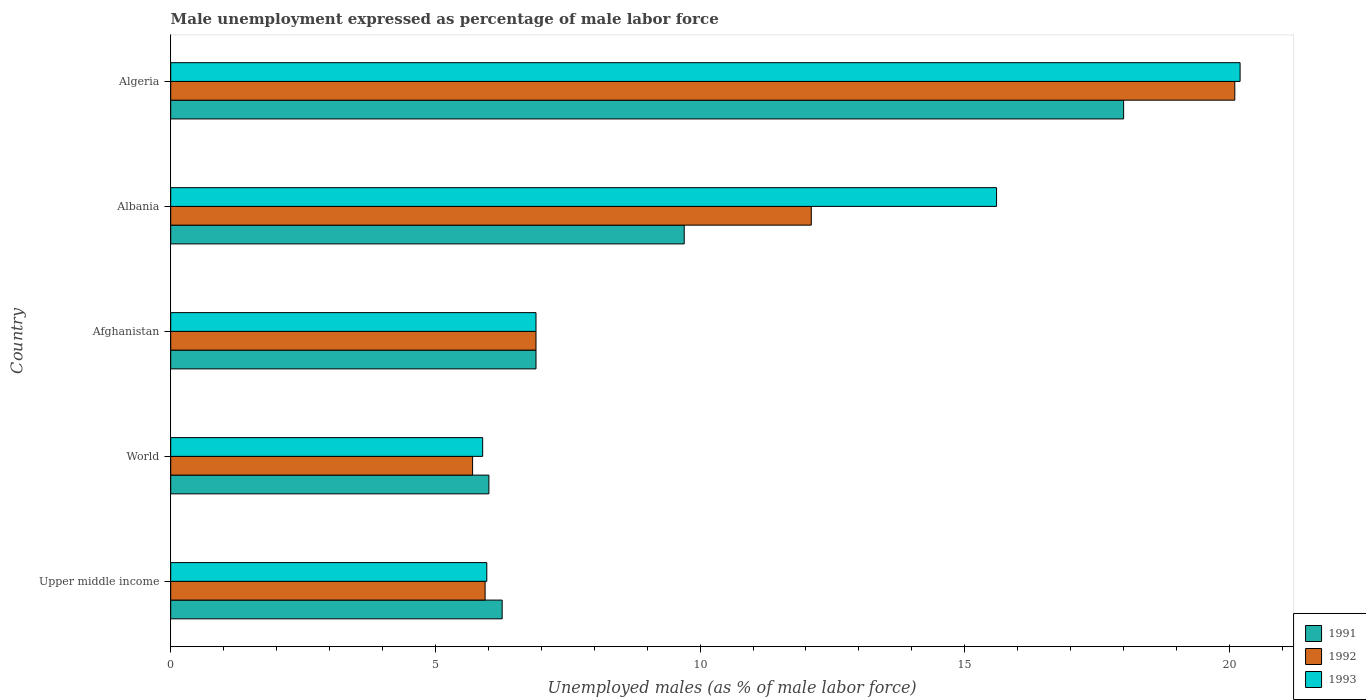How many groups of bars are there?
Your response must be concise. 5. Are the number of bars per tick equal to the number of legend labels?
Offer a terse response. Yes. Are the number of bars on each tick of the Y-axis equal?
Offer a terse response. Yes. How many bars are there on the 2nd tick from the top?
Offer a very short reply. 3. How many bars are there on the 5th tick from the bottom?
Your answer should be very brief. 3. What is the label of the 5th group of bars from the top?
Ensure brevity in your answer.  Upper middle income. In how many cases, is the number of bars for a given country not equal to the number of legend labels?
Offer a very short reply. 0. What is the unemployment in males in in 1992 in Afghanistan?
Offer a terse response. 6.9. Across all countries, what is the maximum unemployment in males in in 1993?
Provide a short and direct response. 20.2. Across all countries, what is the minimum unemployment in males in in 1993?
Provide a short and direct response. 5.89. In which country was the unemployment in males in in 1992 maximum?
Your answer should be compact. Algeria. What is the total unemployment in males in in 1991 in the graph?
Your response must be concise. 46.87. What is the difference between the unemployment in males in in 1993 in Afghanistan and that in Algeria?
Keep it short and to the point. -13.3. What is the difference between the unemployment in males in in 1992 in Albania and the unemployment in males in in 1993 in Upper middle income?
Keep it short and to the point. 6.13. What is the average unemployment in males in in 1991 per country?
Your answer should be very brief. 9.37. What is the difference between the unemployment in males in in 1991 and unemployment in males in in 1993 in Albania?
Your response must be concise. -5.9. What is the ratio of the unemployment in males in in 1992 in Afghanistan to that in Upper middle income?
Your answer should be very brief. 1.16. What is the difference between the highest and the second highest unemployment in males in in 1993?
Provide a succinct answer. 4.6. What is the difference between the highest and the lowest unemployment in males in in 1992?
Give a very brief answer. 14.4. In how many countries, is the unemployment in males in in 1993 greater than the average unemployment in males in in 1993 taken over all countries?
Your answer should be very brief. 2. What does the 2nd bar from the top in Afghanistan represents?
Ensure brevity in your answer.  1992. What does the 3rd bar from the bottom in Upper middle income represents?
Provide a succinct answer. 1993. How many bars are there?
Make the answer very short. 15. How many countries are there in the graph?
Offer a terse response. 5. Does the graph contain grids?
Offer a very short reply. No. Where does the legend appear in the graph?
Provide a succinct answer. Bottom right. How are the legend labels stacked?
Keep it short and to the point. Vertical. What is the title of the graph?
Ensure brevity in your answer.  Male unemployment expressed as percentage of male labor force. Does "1982" appear as one of the legend labels in the graph?
Make the answer very short. No. What is the label or title of the X-axis?
Your answer should be very brief. Unemployed males (as % of male labor force). What is the label or title of the Y-axis?
Ensure brevity in your answer.  Country. What is the Unemployed males (as % of male labor force) in 1991 in Upper middle income?
Your answer should be very brief. 6.26. What is the Unemployed males (as % of male labor force) of 1992 in Upper middle income?
Your response must be concise. 5.94. What is the Unemployed males (as % of male labor force) of 1993 in Upper middle income?
Provide a short and direct response. 5.97. What is the Unemployed males (as % of male labor force) in 1991 in World?
Your response must be concise. 6.01. What is the Unemployed males (as % of male labor force) of 1992 in World?
Keep it short and to the point. 5.7. What is the Unemployed males (as % of male labor force) of 1993 in World?
Your answer should be very brief. 5.89. What is the Unemployed males (as % of male labor force) of 1991 in Afghanistan?
Provide a short and direct response. 6.9. What is the Unemployed males (as % of male labor force) in 1992 in Afghanistan?
Offer a very short reply. 6.9. What is the Unemployed males (as % of male labor force) in 1993 in Afghanistan?
Your answer should be compact. 6.9. What is the Unemployed males (as % of male labor force) in 1991 in Albania?
Give a very brief answer. 9.7. What is the Unemployed males (as % of male labor force) in 1992 in Albania?
Your answer should be compact. 12.1. What is the Unemployed males (as % of male labor force) of 1993 in Albania?
Provide a succinct answer. 15.6. What is the Unemployed males (as % of male labor force) in 1991 in Algeria?
Make the answer very short. 18. What is the Unemployed males (as % of male labor force) of 1992 in Algeria?
Make the answer very short. 20.1. What is the Unemployed males (as % of male labor force) in 1993 in Algeria?
Your response must be concise. 20.2. Across all countries, what is the maximum Unemployed males (as % of male labor force) in 1992?
Provide a short and direct response. 20.1. Across all countries, what is the maximum Unemployed males (as % of male labor force) in 1993?
Your answer should be compact. 20.2. Across all countries, what is the minimum Unemployed males (as % of male labor force) in 1991?
Give a very brief answer. 6.01. Across all countries, what is the minimum Unemployed males (as % of male labor force) in 1992?
Provide a short and direct response. 5.7. Across all countries, what is the minimum Unemployed males (as % of male labor force) in 1993?
Make the answer very short. 5.89. What is the total Unemployed males (as % of male labor force) in 1991 in the graph?
Provide a succinct answer. 46.87. What is the total Unemployed males (as % of male labor force) in 1992 in the graph?
Your answer should be very brief. 50.74. What is the total Unemployed males (as % of male labor force) in 1993 in the graph?
Make the answer very short. 54.56. What is the difference between the Unemployed males (as % of male labor force) of 1991 in Upper middle income and that in World?
Make the answer very short. 0.25. What is the difference between the Unemployed males (as % of male labor force) of 1992 in Upper middle income and that in World?
Offer a terse response. 0.24. What is the difference between the Unemployed males (as % of male labor force) in 1993 in Upper middle income and that in World?
Give a very brief answer. 0.08. What is the difference between the Unemployed males (as % of male labor force) of 1991 in Upper middle income and that in Afghanistan?
Ensure brevity in your answer.  -0.64. What is the difference between the Unemployed males (as % of male labor force) in 1992 in Upper middle income and that in Afghanistan?
Provide a short and direct response. -0.96. What is the difference between the Unemployed males (as % of male labor force) in 1993 in Upper middle income and that in Afghanistan?
Give a very brief answer. -0.93. What is the difference between the Unemployed males (as % of male labor force) in 1991 in Upper middle income and that in Albania?
Offer a very short reply. -3.44. What is the difference between the Unemployed males (as % of male labor force) in 1992 in Upper middle income and that in Albania?
Offer a terse response. -6.16. What is the difference between the Unemployed males (as % of male labor force) in 1993 in Upper middle income and that in Albania?
Provide a succinct answer. -9.63. What is the difference between the Unemployed males (as % of male labor force) of 1991 in Upper middle income and that in Algeria?
Keep it short and to the point. -11.74. What is the difference between the Unemployed males (as % of male labor force) of 1992 in Upper middle income and that in Algeria?
Provide a short and direct response. -14.16. What is the difference between the Unemployed males (as % of male labor force) of 1993 in Upper middle income and that in Algeria?
Keep it short and to the point. -14.23. What is the difference between the Unemployed males (as % of male labor force) of 1991 in World and that in Afghanistan?
Offer a very short reply. -0.89. What is the difference between the Unemployed males (as % of male labor force) in 1992 in World and that in Afghanistan?
Your answer should be very brief. -1.2. What is the difference between the Unemployed males (as % of male labor force) in 1993 in World and that in Afghanistan?
Your answer should be compact. -1.01. What is the difference between the Unemployed males (as % of male labor force) in 1991 in World and that in Albania?
Your answer should be compact. -3.69. What is the difference between the Unemployed males (as % of male labor force) of 1992 in World and that in Albania?
Make the answer very short. -6.4. What is the difference between the Unemployed males (as % of male labor force) of 1993 in World and that in Albania?
Make the answer very short. -9.71. What is the difference between the Unemployed males (as % of male labor force) in 1991 in World and that in Algeria?
Your response must be concise. -11.99. What is the difference between the Unemployed males (as % of male labor force) in 1992 in World and that in Algeria?
Make the answer very short. -14.4. What is the difference between the Unemployed males (as % of male labor force) in 1993 in World and that in Algeria?
Ensure brevity in your answer.  -14.31. What is the difference between the Unemployed males (as % of male labor force) of 1991 in Afghanistan and that in Albania?
Your response must be concise. -2.8. What is the difference between the Unemployed males (as % of male labor force) of 1992 in Afghanistan and that in Albania?
Offer a terse response. -5.2. What is the difference between the Unemployed males (as % of male labor force) in 1993 in Afghanistan and that in Albania?
Offer a terse response. -8.7. What is the difference between the Unemployed males (as % of male labor force) in 1991 in Afghanistan and that in Algeria?
Keep it short and to the point. -11.1. What is the difference between the Unemployed males (as % of male labor force) in 1992 in Afghanistan and that in Algeria?
Make the answer very short. -13.2. What is the difference between the Unemployed males (as % of male labor force) in 1993 in Afghanistan and that in Algeria?
Offer a very short reply. -13.3. What is the difference between the Unemployed males (as % of male labor force) in 1991 in Upper middle income and the Unemployed males (as % of male labor force) in 1992 in World?
Provide a succinct answer. 0.56. What is the difference between the Unemployed males (as % of male labor force) in 1991 in Upper middle income and the Unemployed males (as % of male labor force) in 1993 in World?
Keep it short and to the point. 0.37. What is the difference between the Unemployed males (as % of male labor force) of 1992 in Upper middle income and the Unemployed males (as % of male labor force) of 1993 in World?
Provide a short and direct response. 0.05. What is the difference between the Unemployed males (as % of male labor force) in 1991 in Upper middle income and the Unemployed males (as % of male labor force) in 1992 in Afghanistan?
Offer a very short reply. -0.64. What is the difference between the Unemployed males (as % of male labor force) in 1991 in Upper middle income and the Unemployed males (as % of male labor force) in 1993 in Afghanistan?
Your response must be concise. -0.64. What is the difference between the Unemployed males (as % of male labor force) in 1992 in Upper middle income and the Unemployed males (as % of male labor force) in 1993 in Afghanistan?
Keep it short and to the point. -0.96. What is the difference between the Unemployed males (as % of male labor force) in 1991 in Upper middle income and the Unemployed males (as % of male labor force) in 1992 in Albania?
Your answer should be very brief. -5.84. What is the difference between the Unemployed males (as % of male labor force) of 1991 in Upper middle income and the Unemployed males (as % of male labor force) of 1993 in Albania?
Ensure brevity in your answer.  -9.34. What is the difference between the Unemployed males (as % of male labor force) of 1992 in Upper middle income and the Unemployed males (as % of male labor force) of 1993 in Albania?
Ensure brevity in your answer.  -9.66. What is the difference between the Unemployed males (as % of male labor force) of 1991 in Upper middle income and the Unemployed males (as % of male labor force) of 1992 in Algeria?
Provide a succinct answer. -13.84. What is the difference between the Unemployed males (as % of male labor force) of 1991 in Upper middle income and the Unemployed males (as % of male labor force) of 1993 in Algeria?
Your response must be concise. -13.94. What is the difference between the Unemployed males (as % of male labor force) in 1992 in Upper middle income and the Unemployed males (as % of male labor force) in 1993 in Algeria?
Give a very brief answer. -14.26. What is the difference between the Unemployed males (as % of male labor force) in 1991 in World and the Unemployed males (as % of male labor force) in 1992 in Afghanistan?
Ensure brevity in your answer.  -0.89. What is the difference between the Unemployed males (as % of male labor force) of 1991 in World and the Unemployed males (as % of male labor force) of 1993 in Afghanistan?
Ensure brevity in your answer.  -0.89. What is the difference between the Unemployed males (as % of male labor force) in 1992 in World and the Unemployed males (as % of male labor force) in 1993 in Afghanistan?
Ensure brevity in your answer.  -1.2. What is the difference between the Unemployed males (as % of male labor force) in 1991 in World and the Unemployed males (as % of male labor force) in 1992 in Albania?
Provide a succinct answer. -6.09. What is the difference between the Unemployed males (as % of male labor force) in 1991 in World and the Unemployed males (as % of male labor force) in 1993 in Albania?
Give a very brief answer. -9.59. What is the difference between the Unemployed males (as % of male labor force) in 1992 in World and the Unemployed males (as % of male labor force) in 1993 in Albania?
Offer a very short reply. -9.9. What is the difference between the Unemployed males (as % of male labor force) in 1991 in World and the Unemployed males (as % of male labor force) in 1992 in Algeria?
Provide a succinct answer. -14.09. What is the difference between the Unemployed males (as % of male labor force) of 1991 in World and the Unemployed males (as % of male labor force) of 1993 in Algeria?
Your response must be concise. -14.19. What is the difference between the Unemployed males (as % of male labor force) in 1992 in World and the Unemployed males (as % of male labor force) in 1993 in Algeria?
Ensure brevity in your answer.  -14.5. What is the difference between the Unemployed males (as % of male labor force) in 1991 in Afghanistan and the Unemployed males (as % of male labor force) in 1992 in Albania?
Ensure brevity in your answer.  -5.2. What is the difference between the Unemployed males (as % of male labor force) in 1992 in Afghanistan and the Unemployed males (as % of male labor force) in 1993 in Albania?
Your answer should be very brief. -8.7. What is the difference between the Unemployed males (as % of male labor force) in 1991 in Afghanistan and the Unemployed males (as % of male labor force) in 1992 in Algeria?
Offer a terse response. -13.2. What is the difference between the Unemployed males (as % of male labor force) in 1992 in Afghanistan and the Unemployed males (as % of male labor force) in 1993 in Algeria?
Give a very brief answer. -13.3. What is the difference between the Unemployed males (as % of male labor force) in 1992 in Albania and the Unemployed males (as % of male labor force) in 1993 in Algeria?
Provide a short and direct response. -8.1. What is the average Unemployed males (as % of male labor force) of 1991 per country?
Your response must be concise. 9.37. What is the average Unemployed males (as % of male labor force) of 1992 per country?
Ensure brevity in your answer.  10.15. What is the average Unemployed males (as % of male labor force) in 1993 per country?
Ensure brevity in your answer.  10.91. What is the difference between the Unemployed males (as % of male labor force) of 1991 and Unemployed males (as % of male labor force) of 1992 in Upper middle income?
Ensure brevity in your answer.  0.32. What is the difference between the Unemployed males (as % of male labor force) in 1991 and Unemployed males (as % of male labor force) in 1993 in Upper middle income?
Give a very brief answer. 0.29. What is the difference between the Unemployed males (as % of male labor force) in 1992 and Unemployed males (as % of male labor force) in 1993 in Upper middle income?
Offer a very short reply. -0.03. What is the difference between the Unemployed males (as % of male labor force) in 1991 and Unemployed males (as % of male labor force) in 1992 in World?
Your response must be concise. 0.31. What is the difference between the Unemployed males (as % of male labor force) in 1991 and Unemployed males (as % of male labor force) in 1993 in World?
Keep it short and to the point. 0.12. What is the difference between the Unemployed males (as % of male labor force) in 1992 and Unemployed males (as % of male labor force) in 1993 in World?
Offer a terse response. -0.19. What is the difference between the Unemployed males (as % of male labor force) of 1991 and Unemployed males (as % of male labor force) of 1992 in Afghanistan?
Your answer should be compact. 0. What is the difference between the Unemployed males (as % of male labor force) of 1992 and Unemployed males (as % of male labor force) of 1993 in Afghanistan?
Offer a very short reply. 0. What is the difference between the Unemployed males (as % of male labor force) of 1992 and Unemployed males (as % of male labor force) of 1993 in Algeria?
Your answer should be very brief. -0.1. What is the ratio of the Unemployed males (as % of male labor force) of 1991 in Upper middle income to that in World?
Offer a very short reply. 1.04. What is the ratio of the Unemployed males (as % of male labor force) in 1992 in Upper middle income to that in World?
Provide a succinct answer. 1.04. What is the ratio of the Unemployed males (as % of male labor force) in 1993 in Upper middle income to that in World?
Your answer should be compact. 1.01. What is the ratio of the Unemployed males (as % of male labor force) in 1991 in Upper middle income to that in Afghanistan?
Offer a very short reply. 0.91. What is the ratio of the Unemployed males (as % of male labor force) of 1992 in Upper middle income to that in Afghanistan?
Provide a succinct answer. 0.86. What is the ratio of the Unemployed males (as % of male labor force) in 1993 in Upper middle income to that in Afghanistan?
Keep it short and to the point. 0.87. What is the ratio of the Unemployed males (as % of male labor force) in 1991 in Upper middle income to that in Albania?
Give a very brief answer. 0.65. What is the ratio of the Unemployed males (as % of male labor force) of 1992 in Upper middle income to that in Albania?
Provide a succinct answer. 0.49. What is the ratio of the Unemployed males (as % of male labor force) of 1993 in Upper middle income to that in Albania?
Offer a very short reply. 0.38. What is the ratio of the Unemployed males (as % of male labor force) in 1991 in Upper middle income to that in Algeria?
Make the answer very short. 0.35. What is the ratio of the Unemployed males (as % of male labor force) of 1992 in Upper middle income to that in Algeria?
Your response must be concise. 0.3. What is the ratio of the Unemployed males (as % of male labor force) in 1993 in Upper middle income to that in Algeria?
Your response must be concise. 0.3. What is the ratio of the Unemployed males (as % of male labor force) of 1991 in World to that in Afghanistan?
Make the answer very short. 0.87. What is the ratio of the Unemployed males (as % of male labor force) of 1992 in World to that in Afghanistan?
Your answer should be compact. 0.83. What is the ratio of the Unemployed males (as % of male labor force) of 1993 in World to that in Afghanistan?
Make the answer very short. 0.85. What is the ratio of the Unemployed males (as % of male labor force) in 1991 in World to that in Albania?
Provide a short and direct response. 0.62. What is the ratio of the Unemployed males (as % of male labor force) in 1992 in World to that in Albania?
Offer a terse response. 0.47. What is the ratio of the Unemployed males (as % of male labor force) of 1993 in World to that in Albania?
Provide a succinct answer. 0.38. What is the ratio of the Unemployed males (as % of male labor force) in 1991 in World to that in Algeria?
Offer a very short reply. 0.33. What is the ratio of the Unemployed males (as % of male labor force) of 1992 in World to that in Algeria?
Provide a short and direct response. 0.28. What is the ratio of the Unemployed males (as % of male labor force) of 1993 in World to that in Algeria?
Ensure brevity in your answer.  0.29. What is the ratio of the Unemployed males (as % of male labor force) in 1991 in Afghanistan to that in Albania?
Your answer should be compact. 0.71. What is the ratio of the Unemployed males (as % of male labor force) in 1992 in Afghanistan to that in Albania?
Provide a short and direct response. 0.57. What is the ratio of the Unemployed males (as % of male labor force) of 1993 in Afghanistan to that in Albania?
Your response must be concise. 0.44. What is the ratio of the Unemployed males (as % of male labor force) of 1991 in Afghanistan to that in Algeria?
Give a very brief answer. 0.38. What is the ratio of the Unemployed males (as % of male labor force) in 1992 in Afghanistan to that in Algeria?
Offer a terse response. 0.34. What is the ratio of the Unemployed males (as % of male labor force) of 1993 in Afghanistan to that in Algeria?
Your response must be concise. 0.34. What is the ratio of the Unemployed males (as % of male labor force) of 1991 in Albania to that in Algeria?
Give a very brief answer. 0.54. What is the ratio of the Unemployed males (as % of male labor force) in 1992 in Albania to that in Algeria?
Ensure brevity in your answer.  0.6. What is the ratio of the Unemployed males (as % of male labor force) of 1993 in Albania to that in Algeria?
Offer a terse response. 0.77. What is the difference between the highest and the second highest Unemployed males (as % of male labor force) in 1992?
Ensure brevity in your answer.  8. What is the difference between the highest and the second highest Unemployed males (as % of male labor force) in 1993?
Offer a terse response. 4.6. What is the difference between the highest and the lowest Unemployed males (as % of male labor force) in 1991?
Provide a short and direct response. 11.99. What is the difference between the highest and the lowest Unemployed males (as % of male labor force) of 1992?
Provide a short and direct response. 14.4. What is the difference between the highest and the lowest Unemployed males (as % of male labor force) of 1993?
Give a very brief answer. 14.31. 